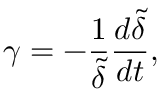<formula> <loc_0><loc_0><loc_500><loc_500>\gamma = - \frac { 1 } { \tilde { \delta } } \frac { d { \tilde { \delta } } } { d t } ,</formula> 